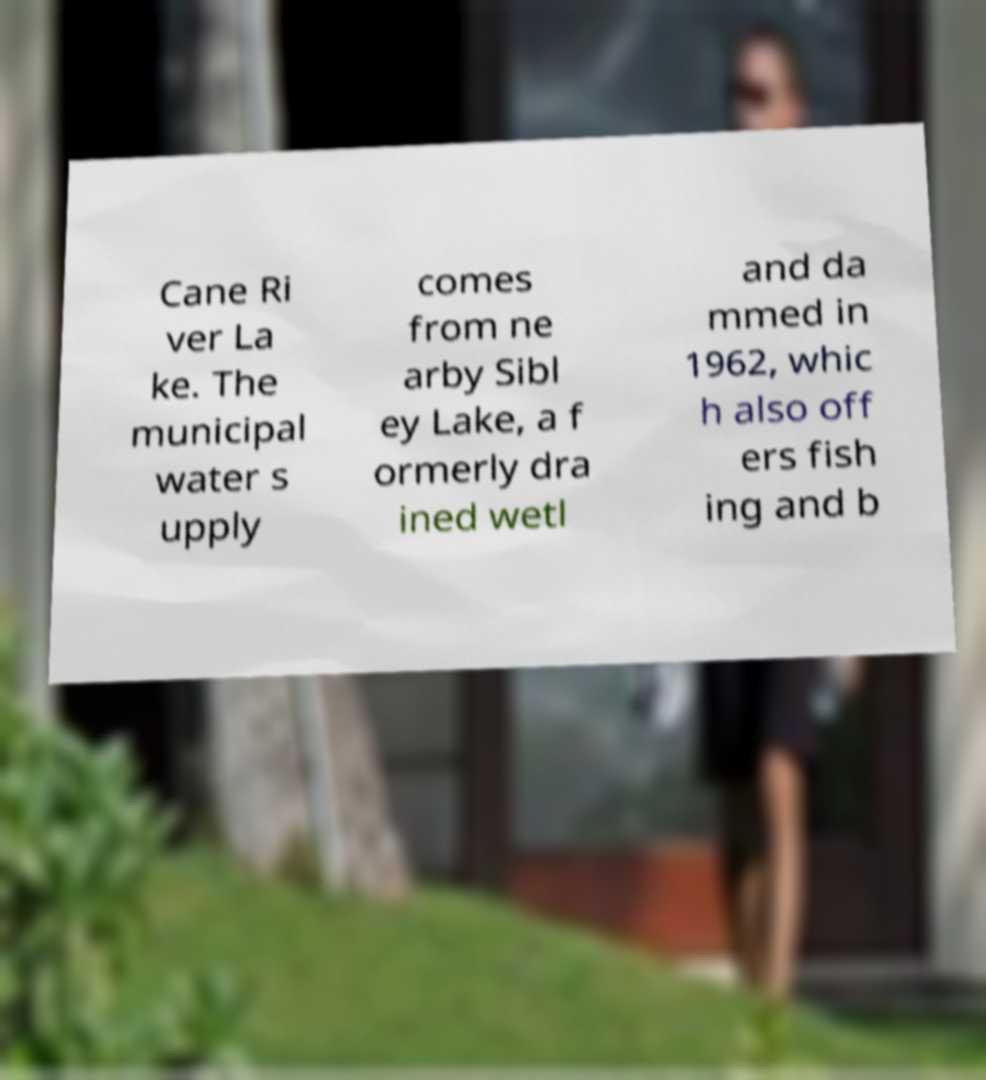Please identify and transcribe the text found in this image. Cane Ri ver La ke. The municipal water s upply comes from ne arby Sibl ey Lake, a f ormerly dra ined wetl and da mmed in 1962, whic h also off ers fish ing and b 